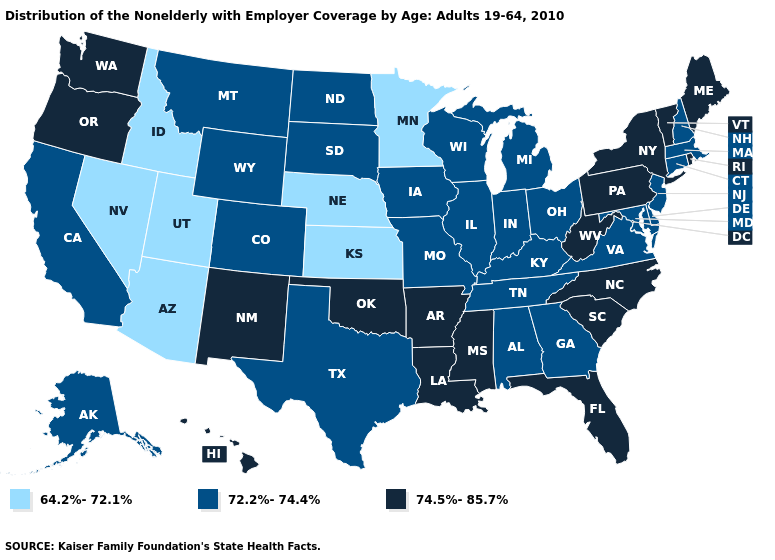What is the lowest value in states that border Arizona?
Give a very brief answer. 64.2%-72.1%. What is the value of Rhode Island?
Answer briefly. 74.5%-85.7%. Does Vermont have the highest value in the USA?
Quick response, please. Yes. Does Montana have a lower value than Colorado?
Keep it brief. No. What is the value of Alaska?
Short answer required. 72.2%-74.4%. Name the states that have a value in the range 64.2%-72.1%?
Write a very short answer. Arizona, Idaho, Kansas, Minnesota, Nebraska, Nevada, Utah. Which states have the lowest value in the USA?
Quick response, please. Arizona, Idaho, Kansas, Minnesota, Nebraska, Nevada, Utah. Does Oklahoma have the highest value in the USA?
Give a very brief answer. Yes. What is the highest value in the USA?
Write a very short answer. 74.5%-85.7%. What is the lowest value in the USA?
Quick response, please. 64.2%-72.1%. What is the value of Alabama?
Write a very short answer. 72.2%-74.4%. Name the states that have a value in the range 64.2%-72.1%?
Give a very brief answer. Arizona, Idaho, Kansas, Minnesota, Nebraska, Nevada, Utah. Name the states that have a value in the range 72.2%-74.4%?
Write a very short answer. Alabama, Alaska, California, Colorado, Connecticut, Delaware, Georgia, Illinois, Indiana, Iowa, Kentucky, Maryland, Massachusetts, Michigan, Missouri, Montana, New Hampshire, New Jersey, North Dakota, Ohio, South Dakota, Tennessee, Texas, Virginia, Wisconsin, Wyoming. Does the map have missing data?
Concise answer only. No. What is the value of New Jersey?
Be succinct. 72.2%-74.4%. 